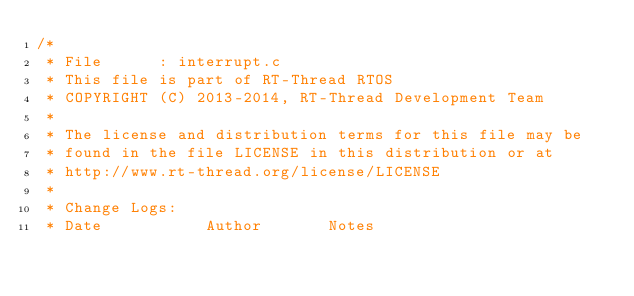<code> <loc_0><loc_0><loc_500><loc_500><_C_>/*
 * File      : interrupt.c
 * This file is part of RT-Thread RTOS
 * COPYRIGHT (C) 2013-2014, RT-Thread Development Team
 *
 * The license and distribution terms for this file may be
 * found in the file LICENSE in this distribution or at
 * http://www.rt-thread.org/license/LICENSE
 *
 * Change Logs:
 * Date           Author       Notes</code> 